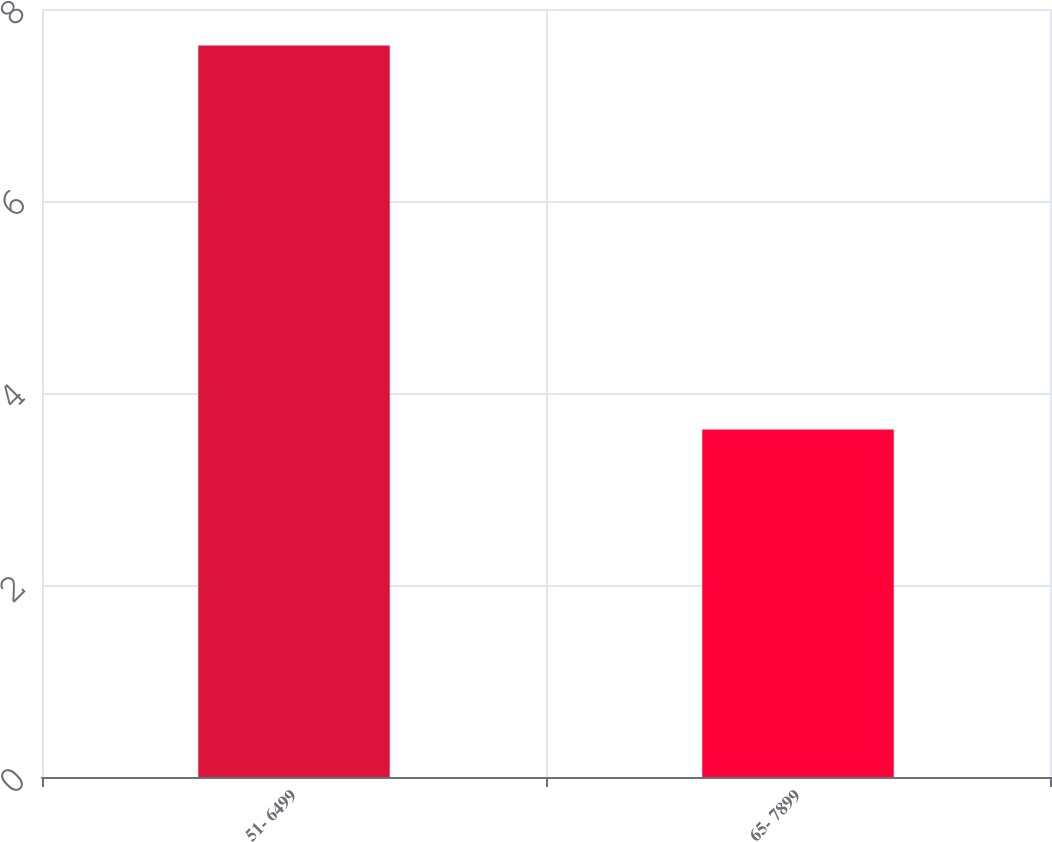Convert chart to OTSL. <chart><loc_0><loc_0><loc_500><loc_500><bar_chart><fcel>51- 6499<fcel>65- 7899<nl><fcel>7.62<fcel>3.62<nl></chart> 